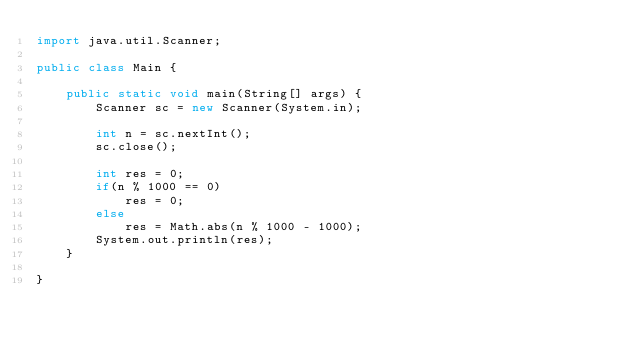<code> <loc_0><loc_0><loc_500><loc_500><_Java_>import java.util.Scanner;

public class Main {

	public static void main(String[] args) {
		Scanner sc = new Scanner(System.in);
		
		int n = sc.nextInt();
		sc.close();
		
		int res = 0;
		if(n % 1000 == 0)
			res = 0;
		else
			res = Math.abs(n % 1000 - 1000);
		System.out.println(res);
	}

}</code> 